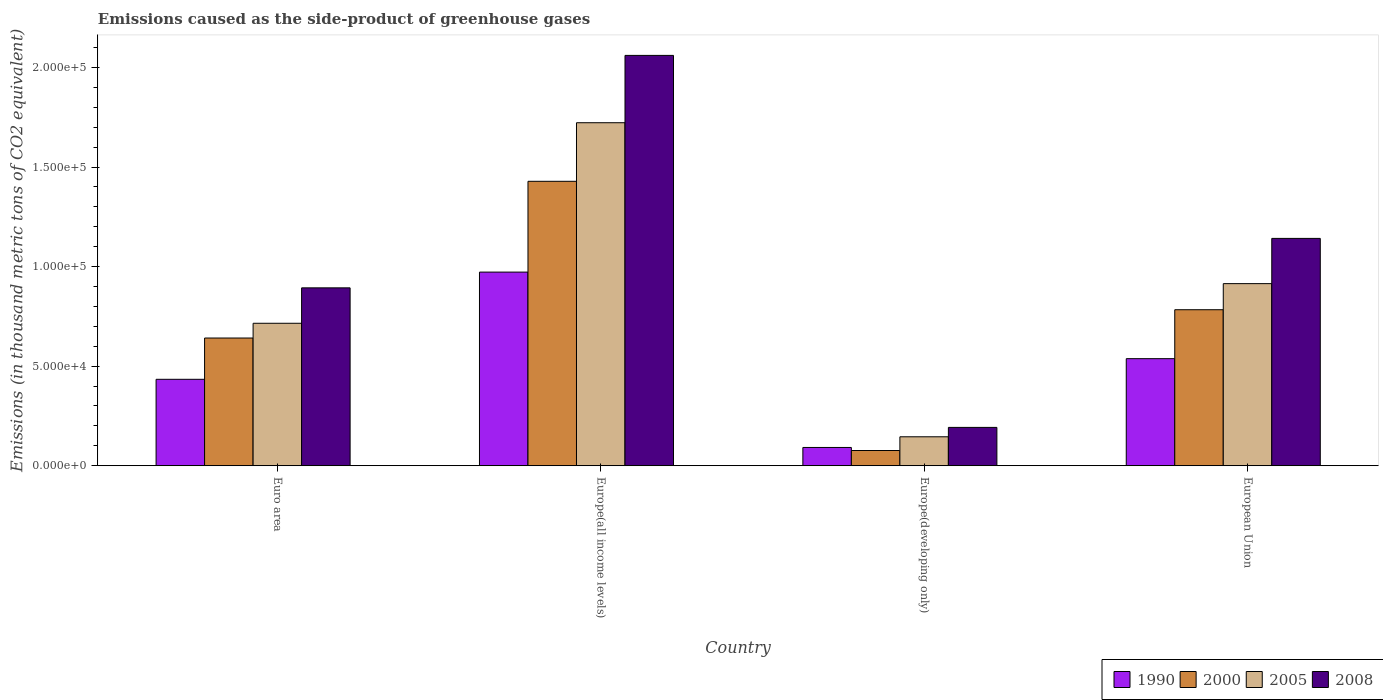How many different coloured bars are there?
Offer a very short reply. 4. How many bars are there on the 4th tick from the right?
Keep it short and to the point. 4. What is the label of the 1st group of bars from the left?
Ensure brevity in your answer.  Euro area. What is the emissions caused as the side-product of greenhouse gases in 2000 in Europe(all income levels)?
Your answer should be compact. 1.43e+05. Across all countries, what is the maximum emissions caused as the side-product of greenhouse gases in 2005?
Ensure brevity in your answer.  1.72e+05. Across all countries, what is the minimum emissions caused as the side-product of greenhouse gases in 1990?
Keep it short and to the point. 9170.1. In which country was the emissions caused as the side-product of greenhouse gases in 2000 maximum?
Your response must be concise. Europe(all income levels). In which country was the emissions caused as the side-product of greenhouse gases in 2005 minimum?
Your answer should be compact. Europe(developing only). What is the total emissions caused as the side-product of greenhouse gases in 2000 in the graph?
Offer a terse response. 2.93e+05. What is the difference between the emissions caused as the side-product of greenhouse gases in 2008 in Europe(all income levels) and that in Europe(developing only)?
Keep it short and to the point. 1.87e+05. What is the difference between the emissions caused as the side-product of greenhouse gases in 2008 in Europe(all income levels) and the emissions caused as the side-product of greenhouse gases in 2005 in Europe(developing only)?
Offer a very short reply. 1.92e+05. What is the average emissions caused as the side-product of greenhouse gases in 1990 per country?
Your answer should be very brief. 5.09e+04. What is the difference between the emissions caused as the side-product of greenhouse gases of/in 1990 and emissions caused as the side-product of greenhouse gases of/in 2000 in Euro area?
Your response must be concise. -2.07e+04. In how many countries, is the emissions caused as the side-product of greenhouse gases in 1990 greater than 140000 thousand metric tons?
Your response must be concise. 0. What is the ratio of the emissions caused as the side-product of greenhouse gases in 1990 in Euro area to that in Europe(all income levels)?
Your response must be concise. 0.45. Is the difference between the emissions caused as the side-product of greenhouse gases in 1990 in Europe(all income levels) and European Union greater than the difference between the emissions caused as the side-product of greenhouse gases in 2000 in Europe(all income levels) and European Union?
Give a very brief answer. No. What is the difference between the highest and the second highest emissions caused as the side-product of greenhouse gases in 2005?
Your answer should be compact. 1.01e+05. What is the difference between the highest and the lowest emissions caused as the side-product of greenhouse gases in 2008?
Offer a very short reply. 1.87e+05. Is the sum of the emissions caused as the side-product of greenhouse gases in 2008 in Euro area and Europe(all income levels) greater than the maximum emissions caused as the side-product of greenhouse gases in 1990 across all countries?
Offer a terse response. Yes. Is it the case that in every country, the sum of the emissions caused as the side-product of greenhouse gases in 2008 and emissions caused as the side-product of greenhouse gases in 1990 is greater than the emissions caused as the side-product of greenhouse gases in 2005?
Ensure brevity in your answer.  Yes. What is the difference between two consecutive major ticks on the Y-axis?
Keep it short and to the point. 5.00e+04. Are the values on the major ticks of Y-axis written in scientific E-notation?
Make the answer very short. Yes. Does the graph contain grids?
Ensure brevity in your answer.  No. What is the title of the graph?
Provide a succinct answer. Emissions caused as the side-product of greenhouse gases. Does "1967" appear as one of the legend labels in the graph?
Your answer should be very brief. No. What is the label or title of the Y-axis?
Keep it short and to the point. Emissions (in thousand metric tons of CO2 equivalent). What is the Emissions (in thousand metric tons of CO2 equivalent) in 1990 in Euro area?
Offer a very short reply. 4.34e+04. What is the Emissions (in thousand metric tons of CO2 equivalent) of 2000 in Euro area?
Keep it short and to the point. 6.41e+04. What is the Emissions (in thousand metric tons of CO2 equivalent) in 2005 in Euro area?
Make the answer very short. 7.15e+04. What is the Emissions (in thousand metric tons of CO2 equivalent) of 2008 in Euro area?
Offer a terse response. 8.93e+04. What is the Emissions (in thousand metric tons of CO2 equivalent) of 1990 in Europe(all income levels)?
Provide a short and direct response. 9.72e+04. What is the Emissions (in thousand metric tons of CO2 equivalent) of 2000 in Europe(all income levels)?
Provide a succinct answer. 1.43e+05. What is the Emissions (in thousand metric tons of CO2 equivalent) in 2005 in Europe(all income levels)?
Provide a succinct answer. 1.72e+05. What is the Emissions (in thousand metric tons of CO2 equivalent) of 2008 in Europe(all income levels)?
Your response must be concise. 2.06e+05. What is the Emissions (in thousand metric tons of CO2 equivalent) in 1990 in Europe(developing only)?
Keep it short and to the point. 9170.1. What is the Emissions (in thousand metric tons of CO2 equivalent) of 2000 in Europe(developing only)?
Your answer should be very brief. 7640.7. What is the Emissions (in thousand metric tons of CO2 equivalent) of 2005 in Europe(developing only)?
Your answer should be very brief. 1.45e+04. What is the Emissions (in thousand metric tons of CO2 equivalent) of 2008 in Europe(developing only)?
Give a very brief answer. 1.92e+04. What is the Emissions (in thousand metric tons of CO2 equivalent) in 1990 in European Union?
Your answer should be very brief. 5.38e+04. What is the Emissions (in thousand metric tons of CO2 equivalent) of 2000 in European Union?
Your answer should be very brief. 7.83e+04. What is the Emissions (in thousand metric tons of CO2 equivalent) in 2005 in European Union?
Keep it short and to the point. 9.14e+04. What is the Emissions (in thousand metric tons of CO2 equivalent) of 2008 in European Union?
Provide a short and direct response. 1.14e+05. Across all countries, what is the maximum Emissions (in thousand metric tons of CO2 equivalent) of 1990?
Provide a succinct answer. 9.72e+04. Across all countries, what is the maximum Emissions (in thousand metric tons of CO2 equivalent) in 2000?
Make the answer very short. 1.43e+05. Across all countries, what is the maximum Emissions (in thousand metric tons of CO2 equivalent) in 2005?
Make the answer very short. 1.72e+05. Across all countries, what is the maximum Emissions (in thousand metric tons of CO2 equivalent) in 2008?
Offer a terse response. 2.06e+05. Across all countries, what is the minimum Emissions (in thousand metric tons of CO2 equivalent) in 1990?
Your answer should be compact. 9170.1. Across all countries, what is the minimum Emissions (in thousand metric tons of CO2 equivalent) in 2000?
Ensure brevity in your answer.  7640.7. Across all countries, what is the minimum Emissions (in thousand metric tons of CO2 equivalent) in 2005?
Keep it short and to the point. 1.45e+04. Across all countries, what is the minimum Emissions (in thousand metric tons of CO2 equivalent) of 2008?
Make the answer very short. 1.92e+04. What is the total Emissions (in thousand metric tons of CO2 equivalent) of 1990 in the graph?
Your answer should be compact. 2.04e+05. What is the total Emissions (in thousand metric tons of CO2 equivalent) in 2000 in the graph?
Make the answer very short. 2.93e+05. What is the total Emissions (in thousand metric tons of CO2 equivalent) in 2005 in the graph?
Ensure brevity in your answer.  3.50e+05. What is the total Emissions (in thousand metric tons of CO2 equivalent) of 2008 in the graph?
Give a very brief answer. 4.29e+05. What is the difference between the Emissions (in thousand metric tons of CO2 equivalent) of 1990 in Euro area and that in Europe(all income levels)?
Make the answer very short. -5.38e+04. What is the difference between the Emissions (in thousand metric tons of CO2 equivalent) in 2000 in Euro area and that in Europe(all income levels)?
Your answer should be compact. -7.87e+04. What is the difference between the Emissions (in thousand metric tons of CO2 equivalent) of 2005 in Euro area and that in Europe(all income levels)?
Give a very brief answer. -1.01e+05. What is the difference between the Emissions (in thousand metric tons of CO2 equivalent) in 2008 in Euro area and that in Europe(all income levels)?
Provide a short and direct response. -1.17e+05. What is the difference between the Emissions (in thousand metric tons of CO2 equivalent) in 1990 in Euro area and that in Europe(developing only)?
Give a very brief answer. 3.42e+04. What is the difference between the Emissions (in thousand metric tons of CO2 equivalent) in 2000 in Euro area and that in Europe(developing only)?
Your answer should be very brief. 5.65e+04. What is the difference between the Emissions (in thousand metric tons of CO2 equivalent) of 2005 in Euro area and that in Europe(developing only)?
Offer a terse response. 5.70e+04. What is the difference between the Emissions (in thousand metric tons of CO2 equivalent) of 2008 in Euro area and that in Europe(developing only)?
Provide a short and direct response. 7.01e+04. What is the difference between the Emissions (in thousand metric tons of CO2 equivalent) in 1990 in Euro area and that in European Union?
Give a very brief answer. -1.04e+04. What is the difference between the Emissions (in thousand metric tons of CO2 equivalent) in 2000 in Euro area and that in European Union?
Your response must be concise. -1.42e+04. What is the difference between the Emissions (in thousand metric tons of CO2 equivalent) in 2005 in Euro area and that in European Union?
Offer a very short reply. -1.99e+04. What is the difference between the Emissions (in thousand metric tons of CO2 equivalent) in 2008 in Euro area and that in European Union?
Offer a very short reply. -2.48e+04. What is the difference between the Emissions (in thousand metric tons of CO2 equivalent) of 1990 in Europe(all income levels) and that in Europe(developing only)?
Your answer should be compact. 8.81e+04. What is the difference between the Emissions (in thousand metric tons of CO2 equivalent) of 2000 in Europe(all income levels) and that in Europe(developing only)?
Your response must be concise. 1.35e+05. What is the difference between the Emissions (in thousand metric tons of CO2 equivalent) in 2005 in Europe(all income levels) and that in Europe(developing only)?
Make the answer very short. 1.58e+05. What is the difference between the Emissions (in thousand metric tons of CO2 equivalent) in 2008 in Europe(all income levels) and that in Europe(developing only)?
Provide a short and direct response. 1.87e+05. What is the difference between the Emissions (in thousand metric tons of CO2 equivalent) in 1990 in Europe(all income levels) and that in European Union?
Provide a short and direct response. 4.35e+04. What is the difference between the Emissions (in thousand metric tons of CO2 equivalent) of 2000 in Europe(all income levels) and that in European Union?
Make the answer very short. 6.45e+04. What is the difference between the Emissions (in thousand metric tons of CO2 equivalent) in 2005 in Europe(all income levels) and that in European Union?
Your answer should be very brief. 8.08e+04. What is the difference between the Emissions (in thousand metric tons of CO2 equivalent) in 2008 in Europe(all income levels) and that in European Union?
Your response must be concise. 9.19e+04. What is the difference between the Emissions (in thousand metric tons of CO2 equivalent) of 1990 in Europe(developing only) and that in European Union?
Ensure brevity in your answer.  -4.46e+04. What is the difference between the Emissions (in thousand metric tons of CO2 equivalent) of 2000 in Europe(developing only) and that in European Union?
Your answer should be very brief. -7.07e+04. What is the difference between the Emissions (in thousand metric tons of CO2 equivalent) of 2005 in Europe(developing only) and that in European Union?
Your answer should be compact. -7.69e+04. What is the difference between the Emissions (in thousand metric tons of CO2 equivalent) of 2008 in Europe(developing only) and that in European Union?
Your answer should be compact. -9.49e+04. What is the difference between the Emissions (in thousand metric tons of CO2 equivalent) of 1990 in Euro area and the Emissions (in thousand metric tons of CO2 equivalent) of 2000 in Europe(all income levels)?
Your answer should be compact. -9.94e+04. What is the difference between the Emissions (in thousand metric tons of CO2 equivalent) of 1990 in Euro area and the Emissions (in thousand metric tons of CO2 equivalent) of 2005 in Europe(all income levels)?
Offer a terse response. -1.29e+05. What is the difference between the Emissions (in thousand metric tons of CO2 equivalent) of 1990 in Euro area and the Emissions (in thousand metric tons of CO2 equivalent) of 2008 in Europe(all income levels)?
Give a very brief answer. -1.63e+05. What is the difference between the Emissions (in thousand metric tons of CO2 equivalent) in 2000 in Euro area and the Emissions (in thousand metric tons of CO2 equivalent) in 2005 in Europe(all income levels)?
Ensure brevity in your answer.  -1.08e+05. What is the difference between the Emissions (in thousand metric tons of CO2 equivalent) of 2000 in Euro area and the Emissions (in thousand metric tons of CO2 equivalent) of 2008 in Europe(all income levels)?
Offer a terse response. -1.42e+05. What is the difference between the Emissions (in thousand metric tons of CO2 equivalent) in 2005 in Euro area and the Emissions (in thousand metric tons of CO2 equivalent) in 2008 in Europe(all income levels)?
Offer a terse response. -1.35e+05. What is the difference between the Emissions (in thousand metric tons of CO2 equivalent) of 1990 in Euro area and the Emissions (in thousand metric tons of CO2 equivalent) of 2000 in Europe(developing only)?
Your response must be concise. 3.58e+04. What is the difference between the Emissions (in thousand metric tons of CO2 equivalent) in 1990 in Euro area and the Emissions (in thousand metric tons of CO2 equivalent) in 2005 in Europe(developing only)?
Offer a terse response. 2.89e+04. What is the difference between the Emissions (in thousand metric tons of CO2 equivalent) of 1990 in Euro area and the Emissions (in thousand metric tons of CO2 equivalent) of 2008 in Europe(developing only)?
Ensure brevity in your answer.  2.42e+04. What is the difference between the Emissions (in thousand metric tons of CO2 equivalent) of 2000 in Euro area and the Emissions (in thousand metric tons of CO2 equivalent) of 2005 in Europe(developing only)?
Your answer should be compact. 4.96e+04. What is the difference between the Emissions (in thousand metric tons of CO2 equivalent) of 2000 in Euro area and the Emissions (in thousand metric tons of CO2 equivalent) of 2008 in Europe(developing only)?
Provide a short and direct response. 4.49e+04. What is the difference between the Emissions (in thousand metric tons of CO2 equivalent) of 2005 in Euro area and the Emissions (in thousand metric tons of CO2 equivalent) of 2008 in Europe(developing only)?
Offer a terse response. 5.23e+04. What is the difference between the Emissions (in thousand metric tons of CO2 equivalent) in 1990 in Euro area and the Emissions (in thousand metric tons of CO2 equivalent) in 2000 in European Union?
Your answer should be compact. -3.49e+04. What is the difference between the Emissions (in thousand metric tons of CO2 equivalent) in 1990 in Euro area and the Emissions (in thousand metric tons of CO2 equivalent) in 2005 in European Union?
Ensure brevity in your answer.  -4.80e+04. What is the difference between the Emissions (in thousand metric tons of CO2 equivalent) in 1990 in Euro area and the Emissions (in thousand metric tons of CO2 equivalent) in 2008 in European Union?
Offer a very short reply. -7.08e+04. What is the difference between the Emissions (in thousand metric tons of CO2 equivalent) in 2000 in Euro area and the Emissions (in thousand metric tons of CO2 equivalent) in 2005 in European Union?
Offer a very short reply. -2.73e+04. What is the difference between the Emissions (in thousand metric tons of CO2 equivalent) in 2000 in Euro area and the Emissions (in thousand metric tons of CO2 equivalent) in 2008 in European Union?
Offer a terse response. -5.00e+04. What is the difference between the Emissions (in thousand metric tons of CO2 equivalent) in 2005 in Euro area and the Emissions (in thousand metric tons of CO2 equivalent) in 2008 in European Union?
Offer a very short reply. -4.26e+04. What is the difference between the Emissions (in thousand metric tons of CO2 equivalent) of 1990 in Europe(all income levels) and the Emissions (in thousand metric tons of CO2 equivalent) of 2000 in Europe(developing only)?
Your response must be concise. 8.96e+04. What is the difference between the Emissions (in thousand metric tons of CO2 equivalent) in 1990 in Europe(all income levels) and the Emissions (in thousand metric tons of CO2 equivalent) in 2005 in Europe(developing only)?
Offer a terse response. 8.27e+04. What is the difference between the Emissions (in thousand metric tons of CO2 equivalent) in 1990 in Europe(all income levels) and the Emissions (in thousand metric tons of CO2 equivalent) in 2008 in Europe(developing only)?
Offer a terse response. 7.80e+04. What is the difference between the Emissions (in thousand metric tons of CO2 equivalent) of 2000 in Europe(all income levels) and the Emissions (in thousand metric tons of CO2 equivalent) of 2005 in Europe(developing only)?
Offer a very short reply. 1.28e+05. What is the difference between the Emissions (in thousand metric tons of CO2 equivalent) in 2000 in Europe(all income levels) and the Emissions (in thousand metric tons of CO2 equivalent) in 2008 in Europe(developing only)?
Ensure brevity in your answer.  1.24e+05. What is the difference between the Emissions (in thousand metric tons of CO2 equivalent) of 2005 in Europe(all income levels) and the Emissions (in thousand metric tons of CO2 equivalent) of 2008 in Europe(developing only)?
Give a very brief answer. 1.53e+05. What is the difference between the Emissions (in thousand metric tons of CO2 equivalent) of 1990 in Europe(all income levels) and the Emissions (in thousand metric tons of CO2 equivalent) of 2000 in European Union?
Your response must be concise. 1.89e+04. What is the difference between the Emissions (in thousand metric tons of CO2 equivalent) in 1990 in Europe(all income levels) and the Emissions (in thousand metric tons of CO2 equivalent) in 2005 in European Union?
Your answer should be compact. 5794.2. What is the difference between the Emissions (in thousand metric tons of CO2 equivalent) of 1990 in Europe(all income levels) and the Emissions (in thousand metric tons of CO2 equivalent) of 2008 in European Union?
Give a very brief answer. -1.69e+04. What is the difference between the Emissions (in thousand metric tons of CO2 equivalent) in 2000 in Europe(all income levels) and the Emissions (in thousand metric tons of CO2 equivalent) in 2005 in European Union?
Ensure brevity in your answer.  5.14e+04. What is the difference between the Emissions (in thousand metric tons of CO2 equivalent) of 2000 in Europe(all income levels) and the Emissions (in thousand metric tons of CO2 equivalent) of 2008 in European Union?
Offer a terse response. 2.87e+04. What is the difference between the Emissions (in thousand metric tons of CO2 equivalent) in 2005 in Europe(all income levels) and the Emissions (in thousand metric tons of CO2 equivalent) in 2008 in European Union?
Give a very brief answer. 5.81e+04. What is the difference between the Emissions (in thousand metric tons of CO2 equivalent) in 1990 in Europe(developing only) and the Emissions (in thousand metric tons of CO2 equivalent) in 2000 in European Union?
Make the answer very short. -6.92e+04. What is the difference between the Emissions (in thousand metric tons of CO2 equivalent) in 1990 in Europe(developing only) and the Emissions (in thousand metric tons of CO2 equivalent) in 2005 in European Union?
Your response must be concise. -8.23e+04. What is the difference between the Emissions (in thousand metric tons of CO2 equivalent) in 1990 in Europe(developing only) and the Emissions (in thousand metric tons of CO2 equivalent) in 2008 in European Union?
Offer a very short reply. -1.05e+05. What is the difference between the Emissions (in thousand metric tons of CO2 equivalent) of 2000 in Europe(developing only) and the Emissions (in thousand metric tons of CO2 equivalent) of 2005 in European Union?
Ensure brevity in your answer.  -8.38e+04. What is the difference between the Emissions (in thousand metric tons of CO2 equivalent) in 2000 in Europe(developing only) and the Emissions (in thousand metric tons of CO2 equivalent) in 2008 in European Union?
Offer a very short reply. -1.07e+05. What is the difference between the Emissions (in thousand metric tons of CO2 equivalent) of 2005 in Europe(developing only) and the Emissions (in thousand metric tons of CO2 equivalent) of 2008 in European Union?
Provide a short and direct response. -9.96e+04. What is the average Emissions (in thousand metric tons of CO2 equivalent) in 1990 per country?
Make the answer very short. 5.09e+04. What is the average Emissions (in thousand metric tons of CO2 equivalent) of 2000 per country?
Offer a terse response. 7.32e+04. What is the average Emissions (in thousand metric tons of CO2 equivalent) of 2005 per country?
Ensure brevity in your answer.  8.74e+04. What is the average Emissions (in thousand metric tons of CO2 equivalent) in 2008 per country?
Offer a very short reply. 1.07e+05. What is the difference between the Emissions (in thousand metric tons of CO2 equivalent) of 1990 and Emissions (in thousand metric tons of CO2 equivalent) of 2000 in Euro area?
Provide a short and direct response. -2.07e+04. What is the difference between the Emissions (in thousand metric tons of CO2 equivalent) in 1990 and Emissions (in thousand metric tons of CO2 equivalent) in 2005 in Euro area?
Offer a very short reply. -2.81e+04. What is the difference between the Emissions (in thousand metric tons of CO2 equivalent) of 1990 and Emissions (in thousand metric tons of CO2 equivalent) of 2008 in Euro area?
Your answer should be compact. -4.59e+04. What is the difference between the Emissions (in thousand metric tons of CO2 equivalent) of 2000 and Emissions (in thousand metric tons of CO2 equivalent) of 2005 in Euro area?
Offer a very short reply. -7401.3. What is the difference between the Emissions (in thousand metric tons of CO2 equivalent) in 2000 and Emissions (in thousand metric tons of CO2 equivalent) in 2008 in Euro area?
Offer a very short reply. -2.52e+04. What is the difference between the Emissions (in thousand metric tons of CO2 equivalent) of 2005 and Emissions (in thousand metric tons of CO2 equivalent) of 2008 in Euro area?
Your answer should be compact. -1.78e+04. What is the difference between the Emissions (in thousand metric tons of CO2 equivalent) in 1990 and Emissions (in thousand metric tons of CO2 equivalent) in 2000 in Europe(all income levels)?
Your response must be concise. -4.56e+04. What is the difference between the Emissions (in thousand metric tons of CO2 equivalent) in 1990 and Emissions (in thousand metric tons of CO2 equivalent) in 2005 in Europe(all income levels)?
Ensure brevity in your answer.  -7.50e+04. What is the difference between the Emissions (in thousand metric tons of CO2 equivalent) in 1990 and Emissions (in thousand metric tons of CO2 equivalent) in 2008 in Europe(all income levels)?
Your response must be concise. -1.09e+05. What is the difference between the Emissions (in thousand metric tons of CO2 equivalent) in 2000 and Emissions (in thousand metric tons of CO2 equivalent) in 2005 in Europe(all income levels)?
Your response must be concise. -2.94e+04. What is the difference between the Emissions (in thousand metric tons of CO2 equivalent) in 2000 and Emissions (in thousand metric tons of CO2 equivalent) in 2008 in Europe(all income levels)?
Offer a terse response. -6.32e+04. What is the difference between the Emissions (in thousand metric tons of CO2 equivalent) in 2005 and Emissions (in thousand metric tons of CO2 equivalent) in 2008 in Europe(all income levels)?
Offer a terse response. -3.38e+04. What is the difference between the Emissions (in thousand metric tons of CO2 equivalent) of 1990 and Emissions (in thousand metric tons of CO2 equivalent) of 2000 in Europe(developing only)?
Your response must be concise. 1529.4. What is the difference between the Emissions (in thousand metric tons of CO2 equivalent) in 1990 and Emissions (in thousand metric tons of CO2 equivalent) in 2005 in Europe(developing only)?
Offer a terse response. -5364. What is the difference between the Emissions (in thousand metric tons of CO2 equivalent) of 1990 and Emissions (in thousand metric tons of CO2 equivalent) of 2008 in Europe(developing only)?
Ensure brevity in your answer.  -1.01e+04. What is the difference between the Emissions (in thousand metric tons of CO2 equivalent) in 2000 and Emissions (in thousand metric tons of CO2 equivalent) in 2005 in Europe(developing only)?
Give a very brief answer. -6893.4. What is the difference between the Emissions (in thousand metric tons of CO2 equivalent) of 2000 and Emissions (in thousand metric tons of CO2 equivalent) of 2008 in Europe(developing only)?
Your response must be concise. -1.16e+04. What is the difference between the Emissions (in thousand metric tons of CO2 equivalent) in 2005 and Emissions (in thousand metric tons of CO2 equivalent) in 2008 in Europe(developing only)?
Offer a terse response. -4714.9. What is the difference between the Emissions (in thousand metric tons of CO2 equivalent) of 1990 and Emissions (in thousand metric tons of CO2 equivalent) of 2000 in European Union?
Your answer should be compact. -2.46e+04. What is the difference between the Emissions (in thousand metric tons of CO2 equivalent) of 1990 and Emissions (in thousand metric tons of CO2 equivalent) of 2005 in European Union?
Make the answer very short. -3.77e+04. What is the difference between the Emissions (in thousand metric tons of CO2 equivalent) of 1990 and Emissions (in thousand metric tons of CO2 equivalent) of 2008 in European Union?
Make the answer very short. -6.04e+04. What is the difference between the Emissions (in thousand metric tons of CO2 equivalent) of 2000 and Emissions (in thousand metric tons of CO2 equivalent) of 2005 in European Union?
Offer a very short reply. -1.31e+04. What is the difference between the Emissions (in thousand metric tons of CO2 equivalent) in 2000 and Emissions (in thousand metric tons of CO2 equivalent) in 2008 in European Union?
Your response must be concise. -3.58e+04. What is the difference between the Emissions (in thousand metric tons of CO2 equivalent) of 2005 and Emissions (in thousand metric tons of CO2 equivalent) of 2008 in European Union?
Offer a very short reply. -2.27e+04. What is the ratio of the Emissions (in thousand metric tons of CO2 equivalent) in 1990 in Euro area to that in Europe(all income levels)?
Offer a very short reply. 0.45. What is the ratio of the Emissions (in thousand metric tons of CO2 equivalent) in 2000 in Euro area to that in Europe(all income levels)?
Ensure brevity in your answer.  0.45. What is the ratio of the Emissions (in thousand metric tons of CO2 equivalent) of 2005 in Euro area to that in Europe(all income levels)?
Provide a succinct answer. 0.42. What is the ratio of the Emissions (in thousand metric tons of CO2 equivalent) of 2008 in Euro area to that in Europe(all income levels)?
Provide a short and direct response. 0.43. What is the ratio of the Emissions (in thousand metric tons of CO2 equivalent) of 1990 in Euro area to that in Europe(developing only)?
Ensure brevity in your answer.  4.73. What is the ratio of the Emissions (in thousand metric tons of CO2 equivalent) in 2000 in Euro area to that in Europe(developing only)?
Your answer should be compact. 8.39. What is the ratio of the Emissions (in thousand metric tons of CO2 equivalent) of 2005 in Euro area to that in Europe(developing only)?
Ensure brevity in your answer.  4.92. What is the ratio of the Emissions (in thousand metric tons of CO2 equivalent) of 2008 in Euro area to that in Europe(developing only)?
Make the answer very short. 4.64. What is the ratio of the Emissions (in thousand metric tons of CO2 equivalent) of 1990 in Euro area to that in European Union?
Your answer should be very brief. 0.81. What is the ratio of the Emissions (in thousand metric tons of CO2 equivalent) of 2000 in Euro area to that in European Union?
Your answer should be very brief. 0.82. What is the ratio of the Emissions (in thousand metric tons of CO2 equivalent) of 2005 in Euro area to that in European Union?
Provide a short and direct response. 0.78. What is the ratio of the Emissions (in thousand metric tons of CO2 equivalent) in 2008 in Euro area to that in European Union?
Your response must be concise. 0.78. What is the ratio of the Emissions (in thousand metric tons of CO2 equivalent) in 1990 in Europe(all income levels) to that in Europe(developing only)?
Offer a very short reply. 10.6. What is the ratio of the Emissions (in thousand metric tons of CO2 equivalent) of 2000 in Europe(all income levels) to that in Europe(developing only)?
Provide a short and direct response. 18.69. What is the ratio of the Emissions (in thousand metric tons of CO2 equivalent) of 2005 in Europe(all income levels) to that in Europe(developing only)?
Your response must be concise. 11.85. What is the ratio of the Emissions (in thousand metric tons of CO2 equivalent) of 2008 in Europe(all income levels) to that in Europe(developing only)?
Your answer should be compact. 10.7. What is the ratio of the Emissions (in thousand metric tons of CO2 equivalent) of 1990 in Europe(all income levels) to that in European Union?
Your response must be concise. 1.81. What is the ratio of the Emissions (in thousand metric tons of CO2 equivalent) in 2000 in Europe(all income levels) to that in European Union?
Ensure brevity in your answer.  1.82. What is the ratio of the Emissions (in thousand metric tons of CO2 equivalent) of 2005 in Europe(all income levels) to that in European Union?
Provide a short and direct response. 1.88. What is the ratio of the Emissions (in thousand metric tons of CO2 equivalent) of 2008 in Europe(all income levels) to that in European Union?
Ensure brevity in your answer.  1.81. What is the ratio of the Emissions (in thousand metric tons of CO2 equivalent) in 1990 in Europe(developing only) to that in European Union?
Your response must be concise. 0.17. What is the ratio of the Emissions (in thousand metric tons of CO2 equivalent) of 2000 in Europe(developing only) to that in European Union?
Provide a succinct answer. 0.1. What is the ratio of the Emissions (in thousand metric tons of CO2 equivalent) in 2005 in Europe(developing only) to that in European Union?
Your answer should be compact. 0.16. What is the ratio of the Emissions (in thousand metric tons of CO2 equivalent) in 2008 in Europe(developing only) to that in European Union?
Offer a very short reply. 0.17. What is the difference between the highest and the second highest Emissions (in thousand metric tons of CO2 equivalent) in 1990?
Your answer should be very brief. 4.35e+04. What is the difference between the highest and the second highest Emissions (in thousand metric tons of CO2 equivalent) in 2000?
Provide a succinct answer. 6.45e+04. What is the difference between the highest and the second highest Emissions (in thousand metric tons of CO2 equivalent) in 2005?
Offer a very short reply. 8.08e+04. What is the difference between the highest and the second highest Emissions (in thousand metric tons of CO2 equivalent) of 2008?
Offer a terse response. 9.19e+04. What is the difference between the highest and the lowest Emissions (in thousand metric tons of CO2 equivalent) of 1990?
Your answer should be very brief. 8.81e+04. What is the difference between the highest and the lowest Emissions (in thousand metric tons of CO2 equivalent) in 2000?
Offer a terse response. 1.35e+05. What is the difference between the highest and the lowest Emissions (in thousand metric tons of CO2 equivalent) of 2005?
Give a very brief answer. 1.58e+05. What is the difference between the highest and the lowest Emissions (in thousand metric tons of CO2 equivalent) in 2008?
Offer a very short reply. 1.87e+05. 